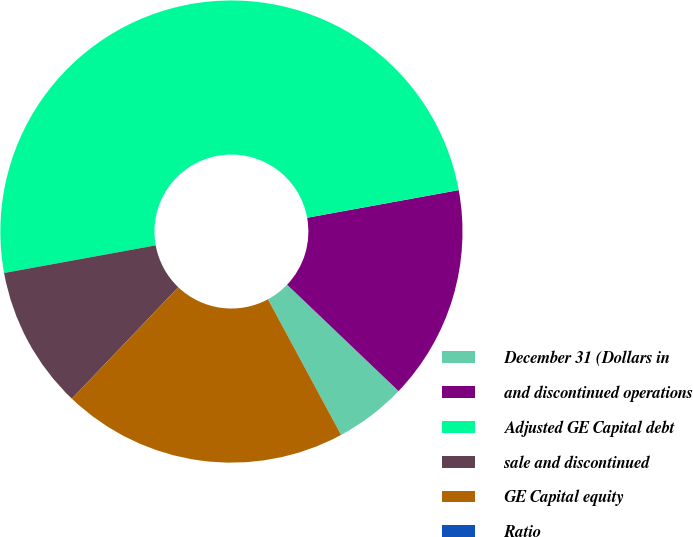Convert chart. <chart><loc_0><loc_0><loc_500><loc_500><pie_chart><fcel>December 31 (Dollars in<fcel>and discontinued operations<fcel>Adjusted GE Capital debt<fcel>sale and discontinued<fcel>GE Capital equity<fcel>Ratio<nl><fcel>5.0%<fcel>15.0%<fcel>50.0%<fcel>10.0%<fcel>20.0%<fcel>0.0%<nl></chart> 